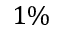<formula> <loc_0><loc_0><loc_500><loc_500>1 \%</formula> 